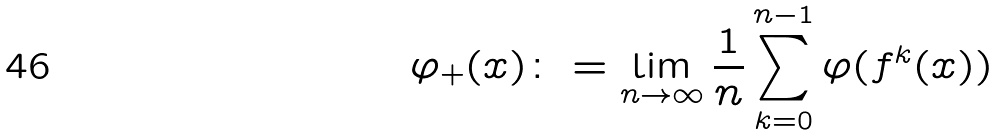<formula> <loc_0><loc_0><loc_500><loc_500>\varphi _ { + } ( x ) \colon = \lim _ { n \rightarrow \infty } \frac { 1 } { n } \sum _ { k = 0 } ^ { n - 1 } \varphi ( f ^ { k } ( x ) )</formula> 